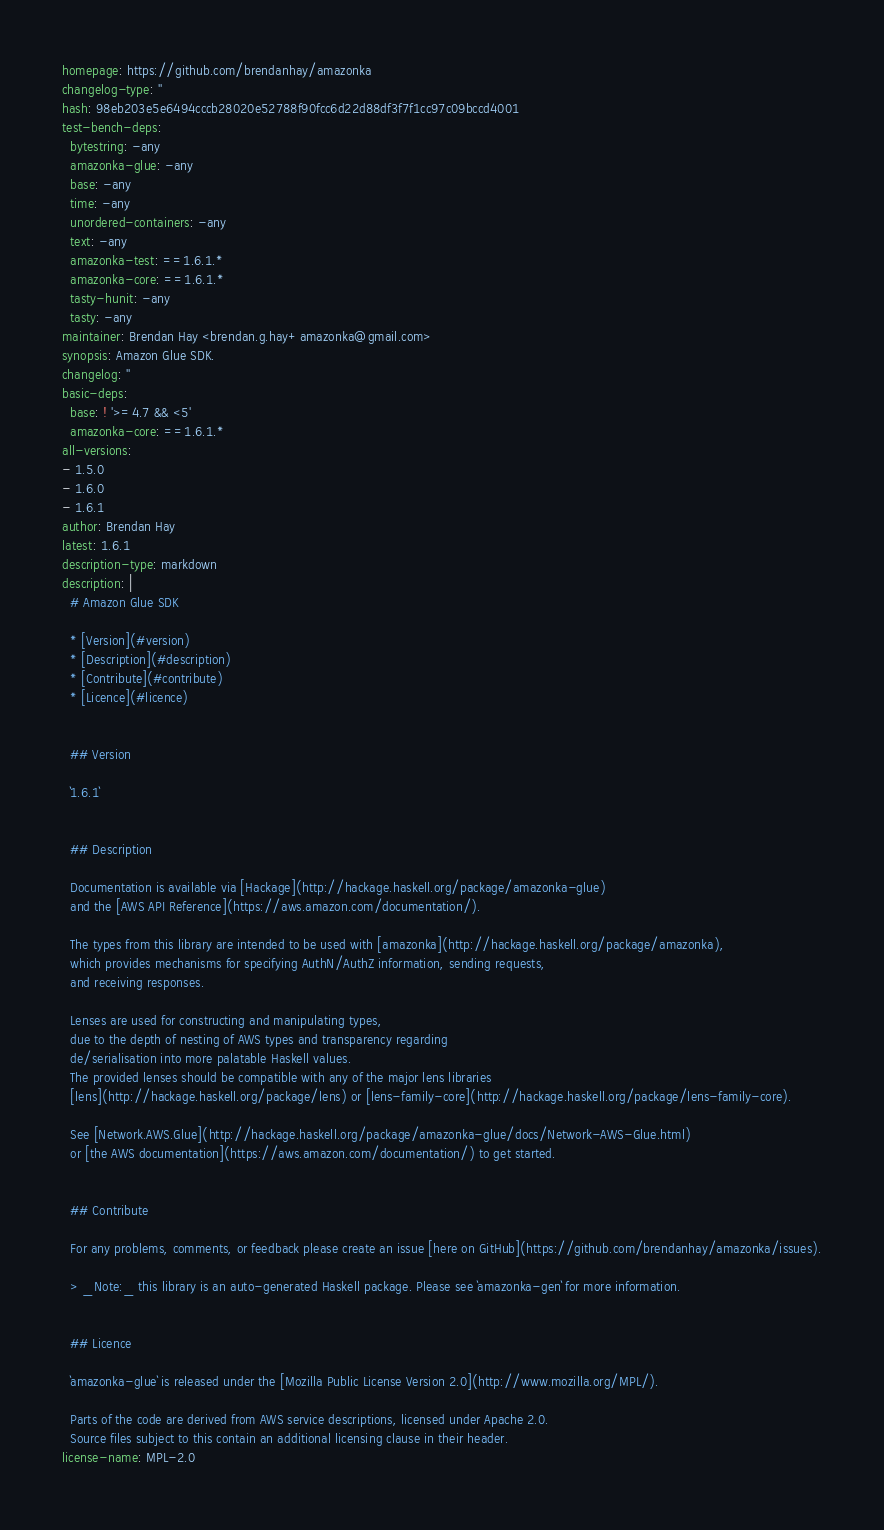Convert code to text. <code><loc_0><loc_0><loc_500><loc_500><_YAML_>homepage: https://github.com/brendanhay/amazonka
changelog-type: ''
hash: 98eb203e5e6494cccb28020e52788f90fcc6d22d88df3f7f1cc97c09bccd4001
test-bench-deps:
  bytestring: -any
  amazonka-glue: -any
  base: -any
  time: -any
  unordered-containers: -any
  text: -any
  amazonka-test: ==1.6.1.*
  amazonka-core: ==1.6.1.*
  tasty-hunit: -any
  tasty: -any
maintainer: Brendan Hay <brendan.g.hay+amazonka@gmail.com>
synopsis: Amazon Glue SDK.
changelog: ''
basic-deps:
  base: ! '>=4.7 && <5'
  amazonka-core: ==1.6.1.*
all-versions:
- 1.5.0
- 1.6.0
- 1.6.1
author: Brendan Hay
latest: 1.6.1
description-type: markdown
description: |
  # Amazon Glue SDK

  * [Version](#version)
  * [Description](#description)
  * [Contribute](#contribute)
  * [Licence](#licence)


  ## Version

  `1.6.1`


  ## Description

  Documentation is available via [Hackage](http://hackage.haskell.org/package/amazonka-glue)
  and the [AWS API Reference](https://aws.amazon.com/documentation/).

  The types from this library are intended to be used with [amazonka](http://hackage.haskell.org/package/amazonka),
  which provides mechanisms for specifying AuthN/AuthZ information, sending requests,
  and receiving responses.

  Lenses are used for constructing and manipulating types,
  due to the depth of nesting of AWS types and transparency regarding
  de/serialisation into more palatable Haskell values.
  The provided lenses should be compatible with any of the major lens libraries
  [lens](http://hackage.haskell.org/package/lens) or [lens-family-core](http://hackage.haskell.org/package/lens-family-core).

  See [Network.AWS.Glue](http://hackage.haskell.org/package/amazonka-glue/docs/Network-AWS-Glue.html)
  or [the AWS documentation](https://aws.amazon.com/documentation/) to get started.


  ## Contribute

  For any problems, comments, or feedback please create an issue [here on GitHub](https://github.com/brendanhay/amazonka/issues).

  > _Note:_ this library is an auto-generated Haskell package. Please see `amazonka-gen` for more information.


  ## Licence

  `amazonka-glue` is released under the [Mozilla Public License Version 2.0](http://www.mozilla.org/MPL/).

  Parts of the code are derived from AWS service descriptions, licensed under Apache 2.0.
  Source files subject to this contain an additional licensing clause in their header.
license-name: MPL-2.0
</code> 